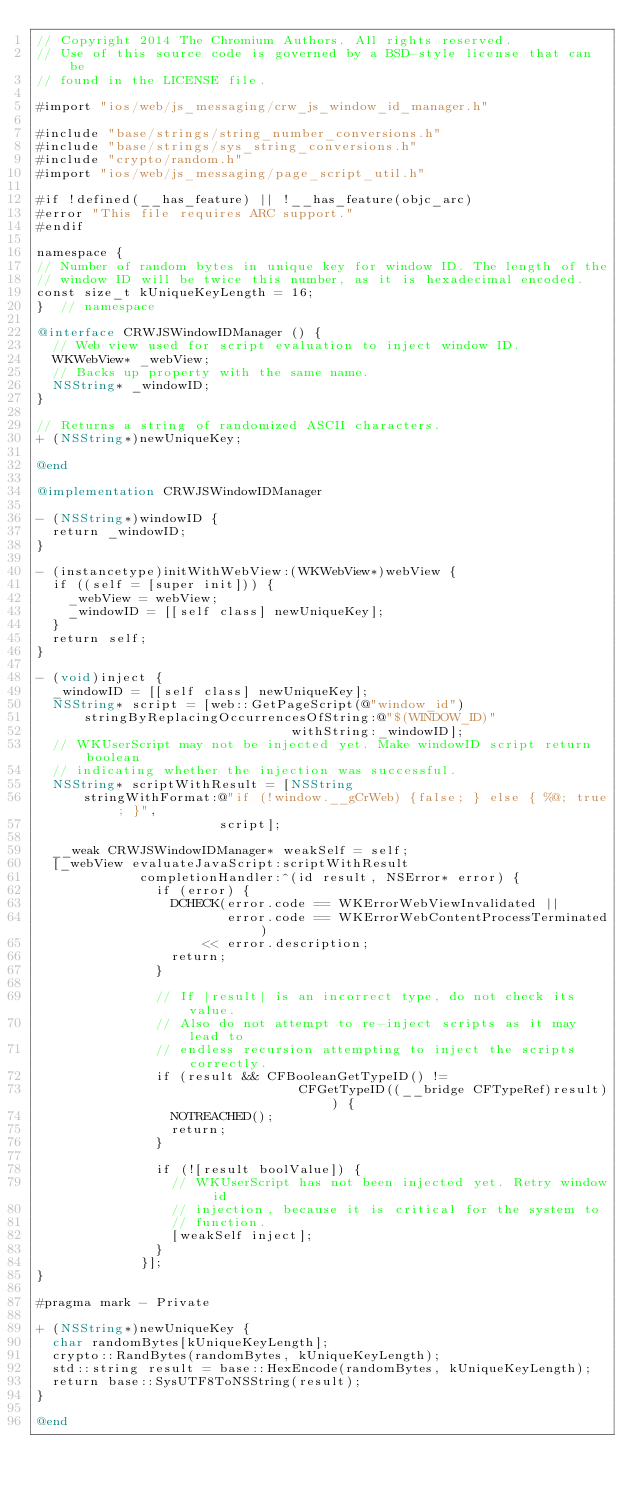Convert code to text. <code><loc_0><loc_0><loc_500><loc_500><_ObjectiveC_>// Copyright 2014 The Chromium Authors. All rights reserved.
// Use of this source code is governed by a BSD-style license that can be
// found in the LICENSE file.

#import "ios/web/js_messaging/crw_js_window_id_manager.h"

#include "base/strings/string_number_conversions.h"
#include "base/strings/sys_string_conversions.h"
#include "crypto/random.h"
#import "ios/web/js_messaging/page_script_util.h"

#if !defined(__has_feature) || !__has_feature(objc_arc)
#error "This file requires ARC support."
#endif

namespace {
// Number of random bytes in unique key for window ID. The length of the
// window ID will be twice this number, as it is hexadecimal encoded.
const size_t kUniqueKeyLength = 16;
}  // namespace

@interface CRWJSWindowIDManager () {
  // Web view used for script evaluation to inject window ID.
  WKWebView* _webView;
  // Backs up property with the same name.
  NSString* _windowID;
}

// Returns a string of randomized ASCII characters.
+ (NSString*)newUniqueKey;

@end

@implementation CRWJSWindowIDManager

- (NSString*)windowID {
  return _windowID;
}

- (instancetype)initWithWebView:(WKWebView*)webView {
  if ((self = [super init])) {
    _webView = webView;
    _windowID = [[self class] newUniqueKey];
  }
  return self;
}

- (void)inject {
  _windowID = [[self class] newUniqueKey];
  NSString* script = [web::GetPageScript(@"window_id")
      stringByReplacingOccurrencesOfString:@"$(WINDOW_ID)"
                                withString:_windowID];
  // WKUserScript may not be injected yet. Make windowID script return boolean
  // indicating whether the injection was successful.
  NSString* scriptWithResult = [NSString
      stringWithFormat:@"if (!window.__gCrWeb) {false; } else { %@; true; }",
                       script];

  __weak CRWJSWindowIDManager* weakSelf = self;
  [_webView evaluateJavaScript:scriptWithResult
             completionHandler:^(id result, NSError* error) {
               if (error) {
                 DCHECK(error.code == WKErrorWebViewInvalidated ||
                        error.code == WKErrorWebContentProcessTerminated)
                     << error.description;
                 return;
               }

               // If |result| is an incorrect type, do not check its value.
               // Also do not attempt to re-inject scripts as it may lead to
               // endless recursion attempting to inject the scripts correctly.
               if (result && CFBooleanGetTypeID() !=
                                 CFGetTypeID((__bridge CFTypeRef)result)) {
                 NOTREACHED();
                 return;
               }

               if (![result boolValue]) {
                 // WKUserScript has not been injected yet. Retry window id
                 // injection, because it is critical for the system to
                 // function.
                 [weakSelf inject];
               }
             }];
}

#pragma mark - Private

+ (NSString*)newUniqueKey {
  char randomBytes[kUniqueKeyLength];
  crypto::RandBytes(randomBytes, kUniqueKeyLength);
  std::string result = base::HexEncode(randomBytes, kUniqueKeyLength);
  return base::SysUTF8ToNSString(result);
}

@end
</code> 